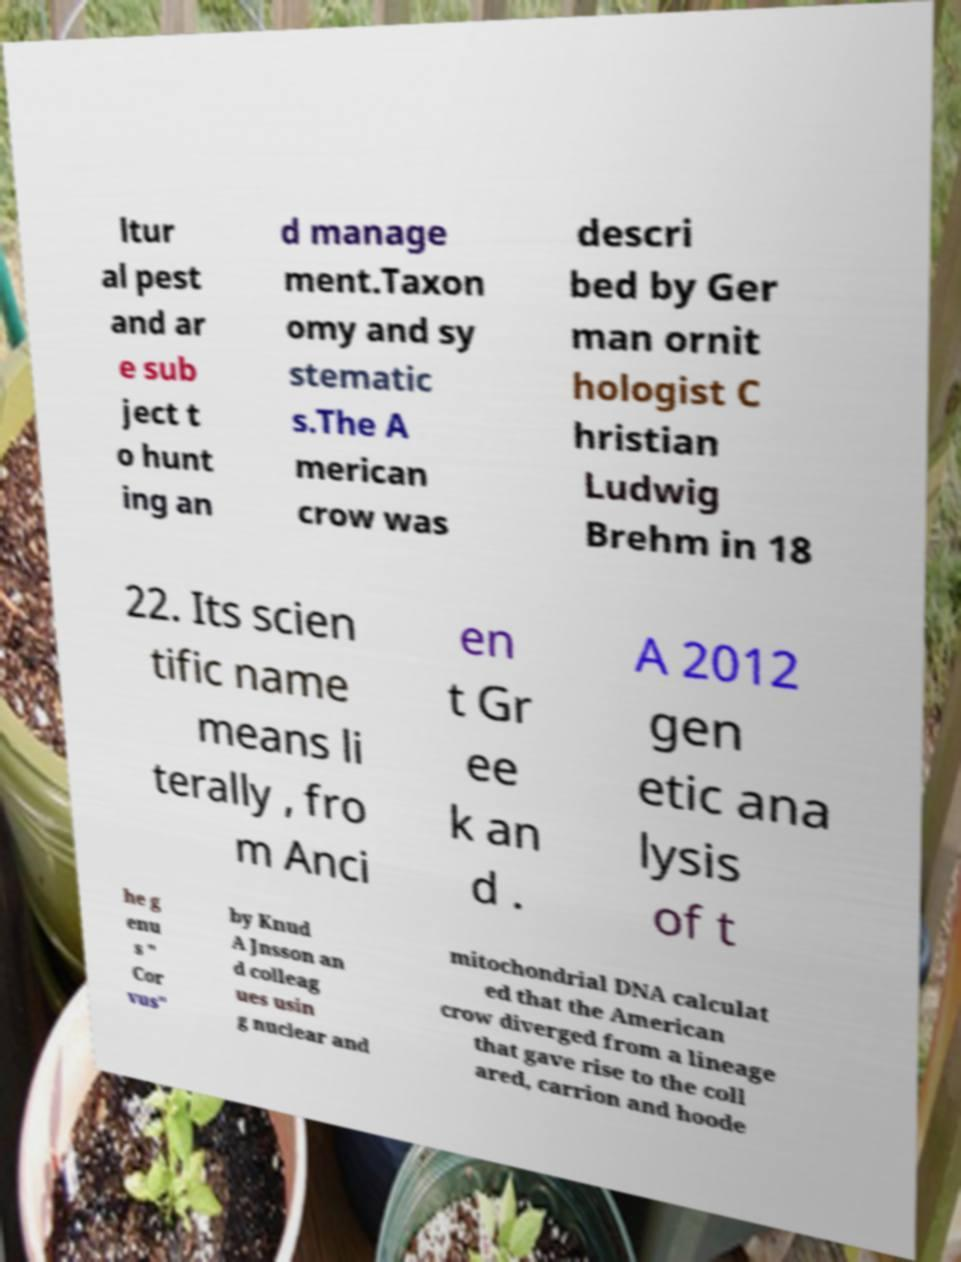Can you read and provide the text displayed in the image?This photo seems to have some interesting text. Can you extract and type it out for me? ltur al pest and ar e sub ject t o hunt ing an d manage ment.Taxon omy and sy stematic s.The A merican crow was descri bed by Ger man ornit hologist C hristian Ludwig Brehm in 18 22. Its scien tific name means li terally , fro m Anci en t Gr ee k an d . A 2012 gen etic ana lysis of t he g enu s " Cor vus" by Knud A Jnsson an d colleag ues usin g nuclear and mitochondrial DNA calculat ed that the American crow diverged from a lineage that gave rise to the coll ared, carrion and hoode 